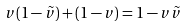Convert formula to latex. <formula><loc_0><loc_0><loc_500><loc_500>v ( 1 - \tilde { v } ) + ( 1 - v ) = 1 - v \tilde { v }</formula> 